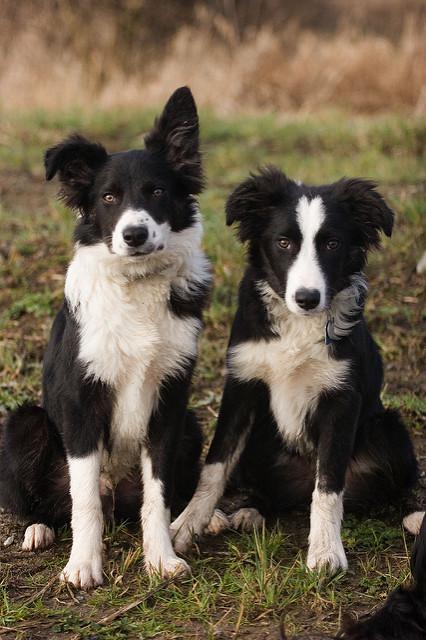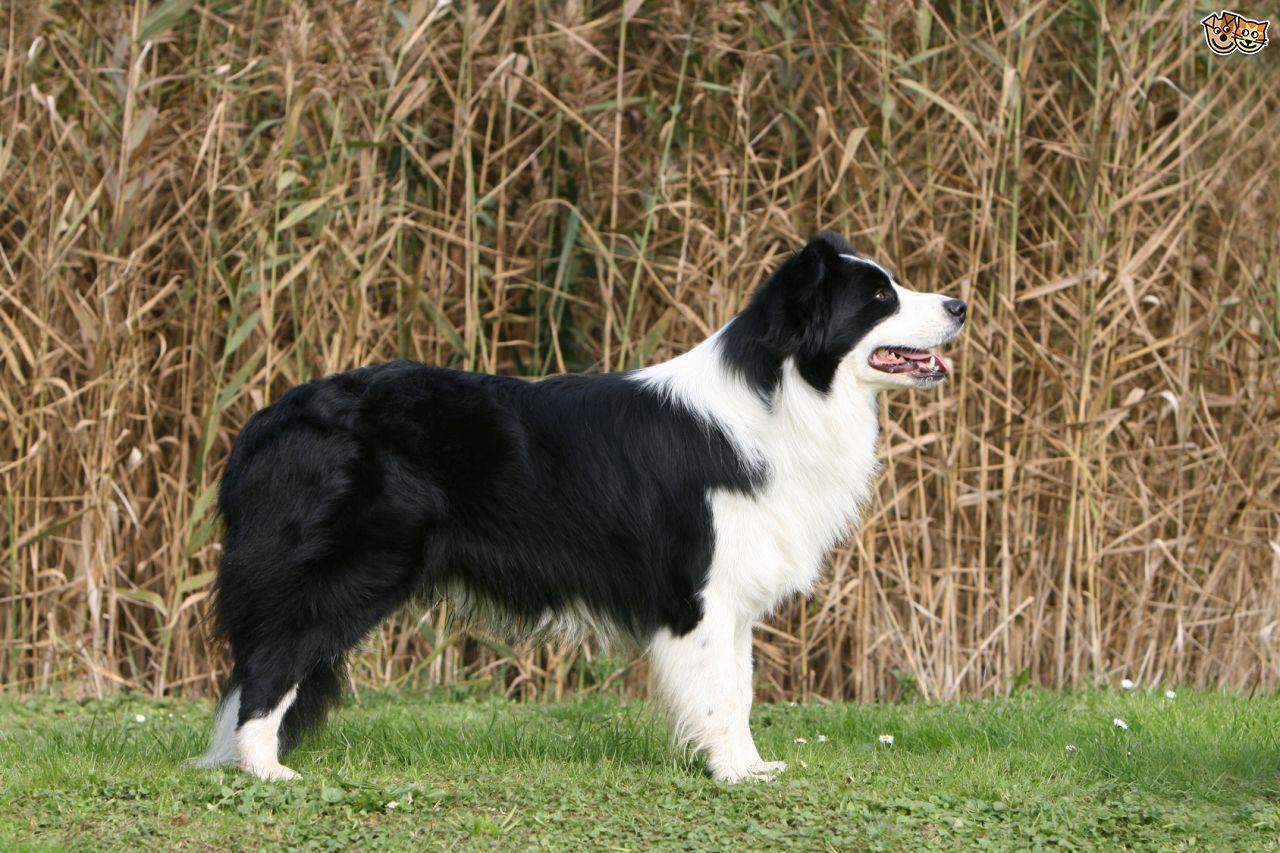The first image is the image on the left, the second image is the image on the right. Evaluate the accuracy of this statement regarding the images: "An image shows a standing dog in profile facing right.". Is it true? Answer yes or no. Yes. The first image is the image on the left, the second image is the image on the right. Analyze the images presented: Is the assertion "One of the images shows exactly two dogs." valid? Answer yes or no. Yes. 